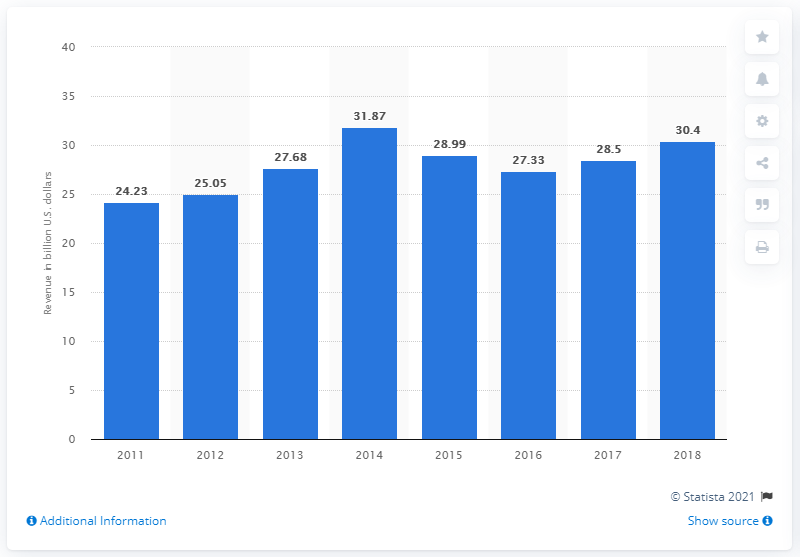List a handful of essential elements in this visual. In the prior fiscal year, 21st Century Fox's revenue was $28.5 million. In the fiscal years 2017-2018, 21st Century Fox generated a total revenue of 58.9 billion dollars. In 2014, 21st Century Fox generated the highest revenue among all the years it has been in operation. In 2018, 21st Century Fox generated a total revenue of 30.4 billion US dollars. 